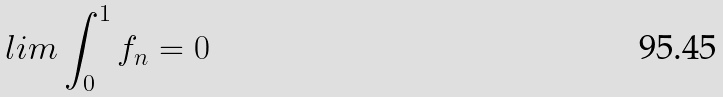Convert formula to latex. <formula><loc_0><loc_0><loc_500><loc_500>l i m \int _ { 0 } ^ { 1 } f _ { n } = 0</formula> 